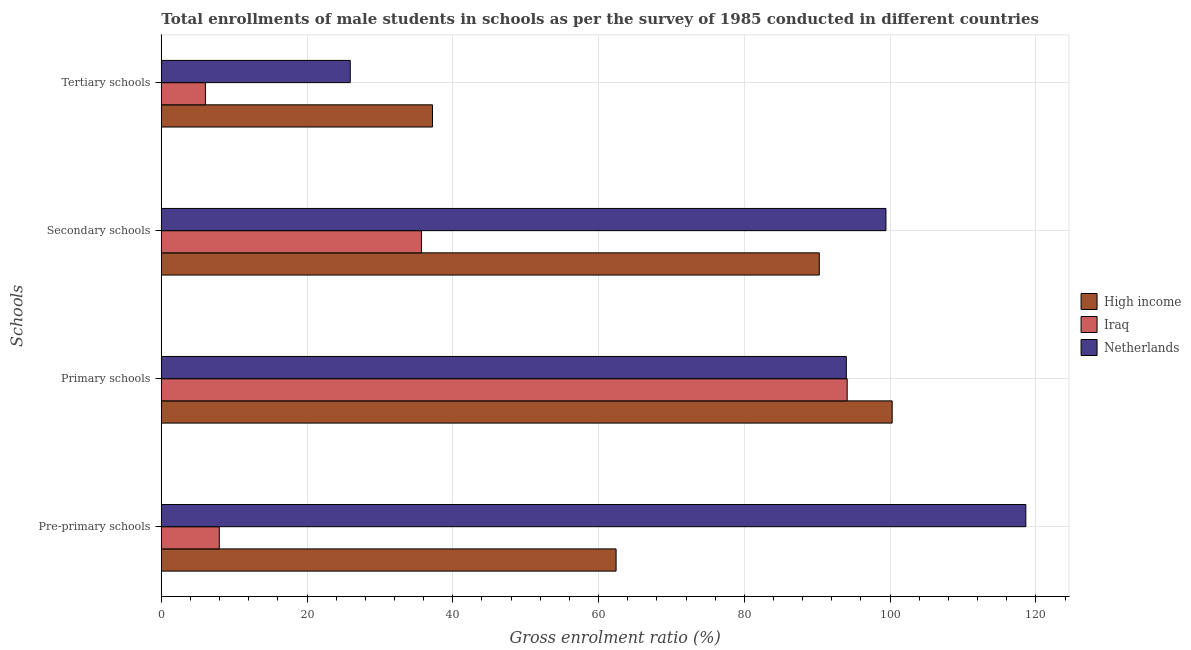How many groups of bars are there?
Offer a very short reply. 4. Are the number of bars per tick equal to the number of legend labels?
Offer a very short reply. Yes. How many bars are there on the 2nd tick from the bottom?
Offer a terse response. 3. What is the label of the 4th group of bars from the top?
Make the answer very short. Pre-primary schools. What is the gross enrolment ratio(male) in tertiary schools in High income?
Your answer should be very brief. 37.21. Across all countries, what is the maximum gross enrolment ratio(male) in secondary schools?
Your response must be concise. 99.43. Across all countries, what is the minimum gross enrolment ratio(male) in primary schools?
Give a very brief answer. 93.99. In which country was the gross enrolment ratio(male) in primary schools minimum?
Your response must be concise. Netherlands. What is the total gross enrolment ratio(male) in primary schools in the graph?
Your response must be concise. 288.39. What is the difference between the gross enrolment ratio(male) in primary schools in Iraq and that in Netherlands?
Ensure brevity in your answer.  0.12. What is the difference between the gross enrolment ratio(male) in primary schools in Iraq and the gross enrolment ratio(male) in tertiary schools in Netherlands?
Keep it short and to the point. 68.19. What is the average gross enrolment ratio(male) in pre-primary schools per country?
Give a very brief answer. 62.99. What is the difference between the gross enrolment ratio(male) in primary schools and gross enrolment ratio(male) in tertiary schools in High income?
Make the answer very short. 63.07. In how many countries, is the gross enrolment ratio(male) in pre-primary schools greater than 100 %?
Keep it short and to the point. 1. What is the ratio of the gross enrolment ratio(male) in primary schools in Iraq to that in High income?
Make the answer very short. 0.94. Is the gross enrolment ratio(male) in secondary schools in High income less than that in Iraq?
Your answer should be very brief. No. What is the difference between the highest and the second highest gross enrolment ratio(male) in secondary schools?
Keep it short and to the point. 9.15. What is the difference between the highest and the lowest gross enrolment ratio(male) in pre-primary schools?
Keep it short and to the point. 110.67. What does the 2nd bar from the top in Secondary schools represents?
Give a very brief answer. Iraq. What does the 2nd bar from the bottom in Secondary schools represents?
Make the answer very short. Iraq. Is it the case that in every country, the sum of the gross enrolment ratio(male) in pre-primary schools and gross enrolment ratio(male) in primary schools is greater than the gross enrolment ratio(male) in secondary schools?
Offer a very short reply. Yes. Are all the bars in the graph horizontal?
Offer a terse response. Yes. What is the difference between two consecutive major ticks on the X-axis?
Your response must be concise. 20. Does the graph contain any zero values?
Your answer should be very brief. No. Does the graph contain grids?
Provide a succinct answer. Yes. How are the legend labels stacked?
Keep it short and to the point. Vertical. What is the title of the graph?
Make the answer very short. Total enrollments of male students in schools as per the survey of 1985 conducted in different countries. What is the label or title of the Y-axis?
Make the answer very short. Schools. What is the Gross enrolment ratio (%) of High income in Pre-primary schools?
Provide a short and direct response. 62.4. What is the Gross enrolment ratio (%) of Iraq in Pre-primary schools?
Make the answer very short. 7.95. What is the Gross enrolment ratio (%) of Netherlands in Pre-primary schools?
Make the answer very short. 118.62. What is the Gross enrolment ratio (%) in High income in Primary schools?
Offer a terse response. 100.28. What is the Gross enrolment ratio (%) in Iraq in Primary schools?
Keep it short and to the point. 94.11. What is the Gross enrolment ratio (%) of Netherlands in Primary schools?
Make the answer very short. 93.99. What is the Gross enrolment ratio (%) of High income in Secondary schools?
Your answer should be very brief. 90.28. What is the Gross enrolment ratio (%) in Iraq in Secondary schools?
Your response must be concise. 35.7. What is the Gross enrolment ratio (%) of Netherlands in Secondary schools?
Give a very brief answer. 99.43. What is the Gross enrolment ratio (%) in High income in Tertiary schools?
Give a very brief answer. 37.21. What is the Gross enrolment ratio (%) in Iraq in Tertiary schools?
Ensure brevity in your answer.  6.05. What is the Gross enrolment ratio (%) of Netherlands in Tertiary schools?
Your response must be concise. 25.93. Across all Schools, what is the maximum Gross enrolment ratio (%) in High income?
Ensure brevity in your answer.  100.28. Across all Schools, what is the maximum Gross enrolment ratio (%) of Iraq?
Your response must be concise. 94.11. Across all Schools, what is the maximum Gross enrolment ratio (%) in Netherlands?
Give a very brief answer. 118.62. Across all Schools, what is the minimum Gross enrolment ratio (%) in High income?
Give a very brief answer. 37.21. Across all Schools, what is the minimum Gross enrolment ratio (%) of Iraq?
Provide a succinct answer. 6.05. Across all Schools, what is the minimum Gross enrolment ratio (%) in Netherlands?
Your answer should be compact. 25.93. What is the total Gross enrolment ratio (%) in High income in the graph?
Keep it short and to the point. 290.18. What is the total Gross enrolment ratio (%) in Iraq in the graph?
Provide a short and direct response. 143.82. What is the total Gross enrolment ratio (%) of Netherlands in the graph?
Give a very brief answer. 337.97. What is the difference between the Gross enrolment ratio (%) in High income in Pre-primary schools and that in Primary schools?
Offer a very short reply. -37.88. What is the difference between the Gross enrolment ratio (%) in Iraq in Pre-primary schools and that in Primary schools?
Give a very brief answer. -86.16. What is the difference between the Gross enrolment ratio (%) of Netherlands in Pre-primary schools and that in Primary schools?
Ensure brevity in your answer.  24.63. What is the difference between the Gross enrolment ratio (%) of High income in Pre-primary schools and that in Secondary schools?
Give a very brief answer. -27.88. What is the difference between the Gross enrolment ratio (%) in Iraq in Pre-primary schools and that in Secondary schools?
Your response must be concise. -27.75. What is the difference between the Gross enrolment ratio (%) in Netherlands in Pre-primary schools and that in Secondary schools?
Keep it short and to the point. 19.19. What is the difference between the Gross enrolment ratio (%) of High income in Pre-primary schools and that in Tertiary schools?
Offer a terse response. 25.19. What is the difference between the Gross enrolment ratio (%) in Iraq in Pre-primary schools and that in Tertiary schools?
Your response must be concise. 1.9. What is the difference between the Gross enrolment ratio (%) in Netherlands in Pre-primary schools and that in Tertiary schools?
Offer a terse response. 92.7. What is the difference between the Gross enrolment ratio (%) of High income in Primary schools and that in Secondary schools?
Ensure brevity in your answer.  10. What is the difference between the Gross enrolment ratio (%) in Iraq in Primary schools and that in Secondary schools?
Your response must be concise. 58.41. What is the difference between the Gross enrolment ratio (%) in Netherlands in Primary schools and that in Secondary schools?
Offer a very short reply. -5.44. What is the difference between the Gross enrolment ratio (%) of High income in Primary schools and that in Tertiary schools?
Offer a terse response. 63.07. What is the difference between the Gross enrolment ratio (%) in Iraq in Primary schools and that in Tertiary schools?
Provide a succinct answer. 88.06. What is the difference between the Gross enrolment ratio (%) in Netherlands in Primary schools and that in Tertiary schools?
Provide a short and direct response. 68.07. What is the difference between the Gross enrolment ratio (%) of High income in Secondary schools and that in Tertiary schools?
Provide a succinct answer. 53.07. What is the difference between the Gross enrolment ratio (%) in Iraq in Secondary schools and that in Tertiary schools?
Offer a very short reply. 29.65. What is the difference between the Gross enrolment ratio (%) in Netherlands in Secondary schools and that in Tertiary schools?
Offer a terse response. 73.5. What is the difference between the Gross enrolment ratio (%) of High income in Pre-primary schools and the Gross enrolment ratio (%) of Iraq in Primary schools?
Your response must be concise. -31.71. What is the difference between the Gross enrolment ratio (%) of High income in Pre-primary schools and the Gross enrolment ratio (%) of Netherlands in Primary schools?
Your answer should be very brief. -31.59. What is the difference between the Gross enrolment ratio (%) in Iraq in Pre-primary schools and the Gross enrolment ratio (%) in Netherlands in Primary schools?
Provide a short and direct response. -86.04. What is the difference between the Gross enrolment ratio (%) in High income in Pre-primary schools and the Gross enrolment ratio (%) in Iraq in Secondary schools?
Give a very brief answer. 26.7. What is the difference between the Gross enrolment ratio (%) of High income in Pre-primary schools and the Gross enrolment ratio (%) of Netherlands in Secondary schools?
Ensure brevity in your answer.  -37.03. What is the difference between the Gross enrolment ratio (%) of Iraq in Pre-primary schools and the Gross enrolment ratio (%) of Netherlands in Secondary schools?
Provide a short and direct response. -91.47. What is the difference between the Gross enrolment ratio (%) of High income in Pre-primary schools and the Gross enrolment ratio (%) of Iraq in Tertiary schools?
Ensure brevity in your answer.  56.35. What is the difference between the Gross enrolment ratio (%) in High income in Pre-primary schools and the Gross enrolment ratio (%) in Netherlands in Tertiary schools?
Provide a short and direct response. 36.48. What is the difference between the Gross enrolment ratio (%) in Iraq in Pre-primary schools and the Gross enrolment ratio (%) in Netherlands in Tertiary schools?
Offer a very short reply. -17.97. What is the difference between the Gross enrolment ratio (%) of High income in Primary schools and the Gross enrolment ratio (%) of Iraq in Secondary schools?
Keep it short and to the point. 64.58. What is the difference between the Gross enrolment ratio (%) in High income in Primary schools and the Gross enrolment ratio (%) in Netherlands in Secondary schools?
Provide a succinct answer. 0.85. What is the difference between the Gross enrolment ratio (%) in Iraq in Primary schools and the Gross enrolment ratio (%) in Netherlands in Secondary schools?
Offer a terse response. -5.32. What is the difference between the Gross enrolment ratio (%) of High income in Primary schools and the Gross enrolment ratio (%) of Iraq in Tertiary schools?
Offer a very short reply. 94.23. What is the difference between the Gross enrolment ratio (%) of High income in Primary schools and the Gross enrolment ratio (%) of Netherlands in Tertiary schools?
Ensure brevity in your answer.  74.36. What is the difference between the Gross enrolment ratio (%) in Iraq in Primary schools and the Gross enrolment ratio (%) in Netherlands in Tertiary schools?
Your answer should be very brief. 68.19. What is the difference between the Gross enrolment ratio (%) in High income in Secondary schools and the Gross enrolment ratio (%) in Iraq in Tertiary schools?
Provide a short and direct response. 84.23. What is the difference between the Gross enrolment ratio (%) of High income in Secondary schools and the Gross enrolment ratio (%) of Netherlands in Tertiary schools?
Provide a short and direct response. 64.36. What is the difference between the Gross enrolment ratio (%) of Iraq in Secondary schools and the Gross enrolment ratio (%) of Netherlands in Tertiary schools?
Give a very brief answer. 9.77. What is the average Gross enrolment ratio (%) of High income per Schools?
Provide a short and direct response. 72.54. What is the average Gross enrolment ratio (%) in Iraq per Schools?
Provide a succinct answer. 35.95. What is the average Gross enrolment ratio (%) of Netherlands per Schools?
Offer a terse response. 84.49. What is the difference between the Gross enrolment ratio (%) in High income and Gross enrolment ratio (%) in Iraq in Pre-primary schools?
Your response must be concise. 54.45. What is the difference between the Gross enrolment ratio (%) in High income and Gross enrolment ratio (%) in Netherlands in Pre-primary schools?
Your response must be concise. -56.22. What is the difference between the Gross enrolment ratio (%) in Iraq and Gross enrolment ratio (%) in Netherlands in Pre-primary schools?
Keep it short and to the point. -110.67. What is the difference between the Gross enrolment ratio (%) in High income and Gross enrolment ratio (%) in Iraq in Primary schools?
Give a very brief answer. 6.17. What is the difference between the Gross enrolment ratio (%) of High income and Gross enrolment ratio (%) of Netherlands in Primary schools?
Provide a short and direct response. 6.29. What is the difference between the Gross enrolment ratio (%) in Iraq and Gross enrolment ratio (%) in Netherlands in Primary schools?
Ensure brevity in your answer.  0.12. What is the difference between the Gross enrolment ratio (%) in High income and Gross enrolment ratio (%) in Iraq in Secondary schools?
Provide a short and direct response. 54.58. What is the difference between the Gross enrolment ratio (%) of High income and Gross enrolment ratio (%) of Netherlands in Secondary schools?
Offer a very short reply. -9.15. What is the difference between the Gross enrolment ratio (%) in Iraq and Gross enrolment ratio (%) in Netherlands in Secondary schools?
Offer a terse response. -63.73. What is the difference between the Gross enrolment ratio (%) in High income and Gross enrolment ratio (%) in Iraq in Tertiary schools?
Your answer should be very brief. 31.16. What is the difference between the Gross enrolment ratio (%) in High income and Gross enrolment ratio (%) in Netherlands in Tertiary schools?
Keep it short and to the point. 11.29. What is the difference between the Gross enrolment ratio (%) in Iraq and Gross enrolment ratio (%) in Netherlands in Tertiary schools?
Keep it short and to the point. -19.87. What is the ratio of the Gross enrolment ratio (%) in High income in Pre-primary schools to that in Primary schools?
Your answer should be very brief. 0.62. What is the ratio of the Gross enrolment ratio (%) of Iraq in Pre-primary schools to that in Primary schools?
Keep it short and to the point. 0.08. What is the ratio of the Gross enrolment ratio (%) of Netherlands in Pre-primary schools to that in Primary schools?
Give a very brief answer. 1.26. What is the ratio of the Gross enrolment ratio (%) in High income in Pre-primary schools to that in Secondary schools?
Your answer should be very brief. 0.69. What is the ratio of the Gross enrolment ratio (%) of Iraq in Pre-primary schools to that in Secondary schools?
Keep it short and to the point. 0.22. What is the ratio of the Gross enrolment ratio (%) of Netherlands in Pre-primary schools to that in Secondary schools?
Make the answer very short. 1.19. What is the ratio of the Gross enrolment ratio (%) of High income in Pre-primary schools to that in Tertiary schools?
Ensure brevity in your answer.  1.68. What is the ratio of the Gross enrolment ratio (%) in Iraq in Pre-primary schools to that in Tertiary schools?
Give a very brief answer. 1.31. What is the ratio of the Gross enrolment ratio (%) in Netherlands in Pre-primary schools to that in Tertiary schools?
Provide a succinct answer. 4.58. What is the ratio of the Gross enrolment ratio (%) in High income in Primary schools to that in Secondary schools?
Make the answer very short. 1.11. What is the ratio of the Gross enrolment ratio (%) of Iraq in Primary schools to that in Secondary schools?
Offer a terse response. 2.64. What is the ratio of the Gross enrolment ratio (%) of Netherlands in Primary schools to that in Secondary schools?
Provide a succinct answer. 0.95. What is the ratio of the Gross enrolment ratio (%) in High income in Primary schools to that in Tertiary schools?
Offer a very short reply. 2.69. What is the ratio of the Gross enrolment ratio (%) of Iraq in Primary schools to that in Tertiary schools?
Your answer should be compact. 15.55. What is the ratio of the Gross enrolment ratio (%) in Netherlands in Primary schools to that in Tertiary schools?
Provide a short and direct response. 3.63. What is the ratio of the Gross enrolment ratio (%) of High income in Secondary schools to that in Tertiary schools?
Ensure brevity in your answer.  2.43. What is the ratio of the Gross enrolment ratio (%) in Iraq in Secondary schools to that in Tertiary schools?
Your response must be concise. 5.9. What is the ratio of the Gross enrolment ratio (%) of Netherlands in Secondary schools to that in Tertiary schools?
Offer a terse response. 3.84. What is the difference between the highest and the second highest Gross enrolment ratio (%) of High income?
Provide a succinct answer. 10. What is the difference between the highest and the second highest Gross enrolment ratio (%) in Iraq?
Keep it short and to the point. 58.41. What is the difference between the highest and the second highest Gross enrolment ratio (%) of Netherlands?
Give a very brief answer. 19.19. What is the difference between the highest and the lowest Gross enrolment ratio (%) of High income?
Make the answer very short. 63.07. What is the difference between the highest and the lowest Gross enrolment ratio (%) in Iraq?
Give a very brief answer. 88.06. What is the difference between the highest and the lowest Gross enrolment ratio (%) of Netherlands?
Keep it short and to the point. 92.7. 